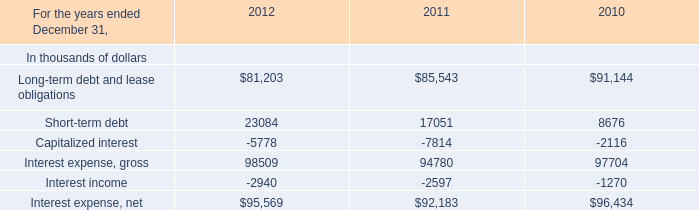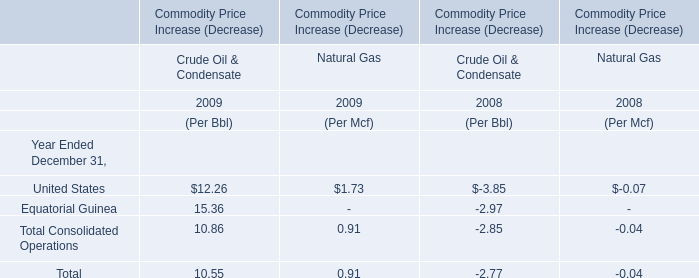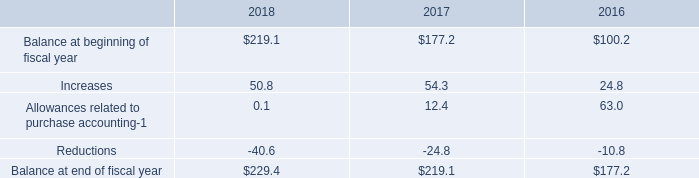by what percent did the balance of deferred tax assets increase between 2016 and 2018? 
Computations: ((229.4 - 177.2) / 177.2)
Answer: 0.29458. 